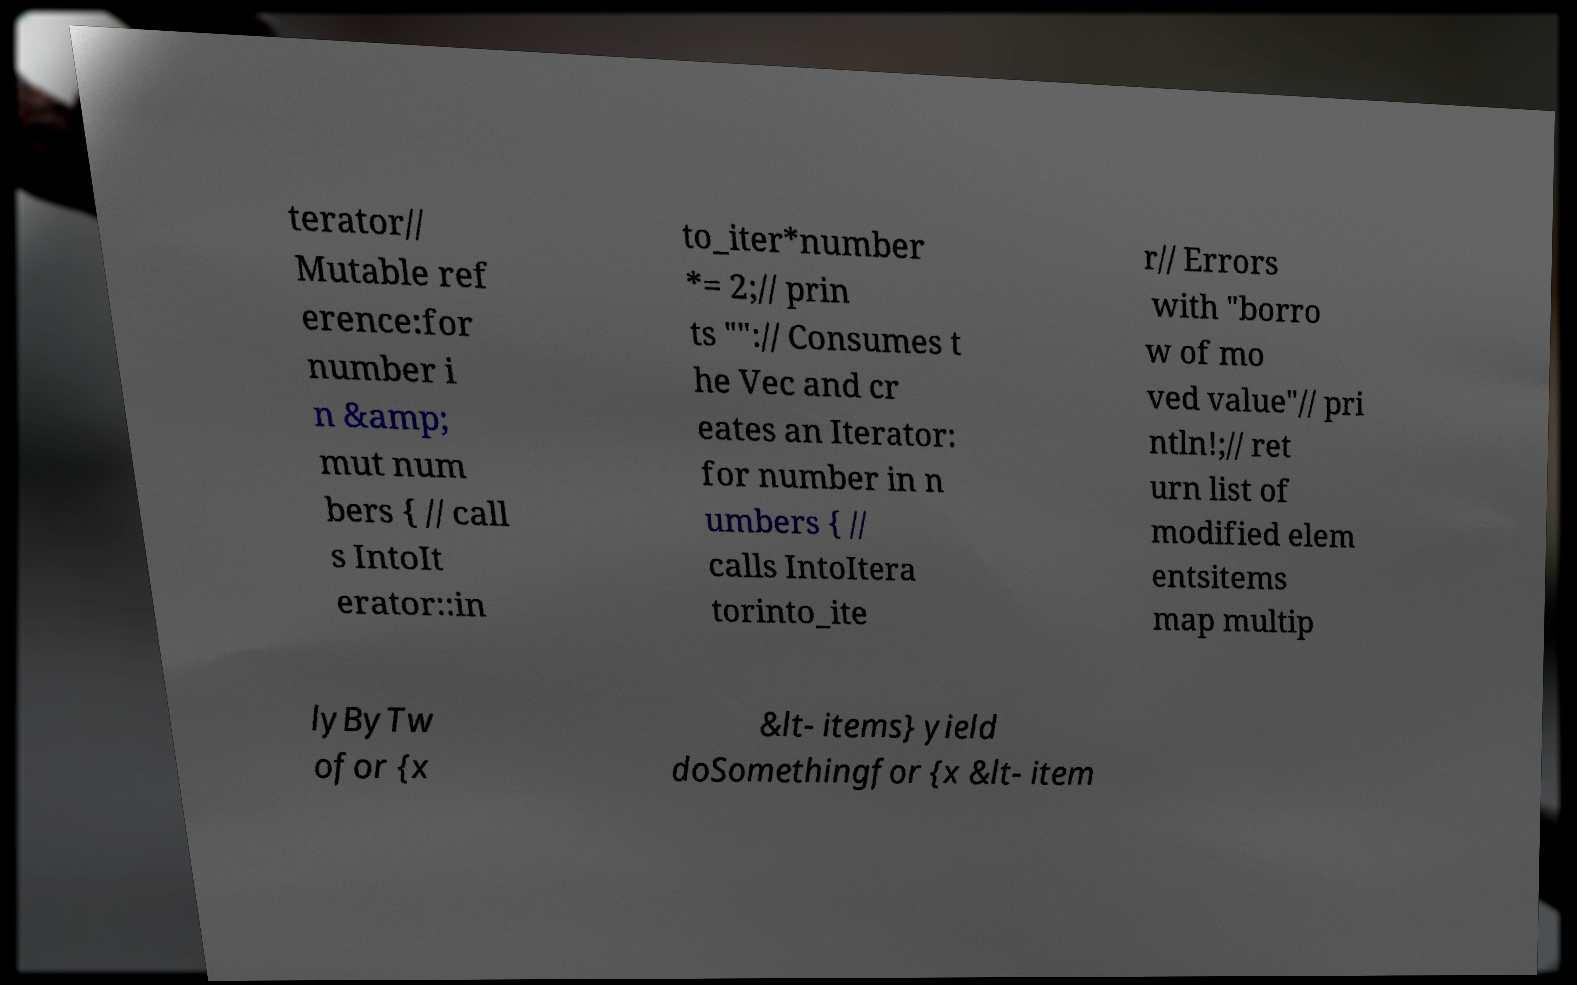Could you extract and type out the text from this image? terator// Mutable ref erence:for number i n &amp; mut num bers { // call s IntoIt erator::in to_iter*number *= 2;// prin ts "":// Consumes t he Vec and cr eates an Iterator: for number in n umbers { // calls IntoItera torinto_ite r// Errors with "borro w of mo ved value"// pri ntln!;// ret urn list of modified elem entsitems map multip lyByTw ofor {x &lt- items} yield doSomethingfor {x &lt- item 